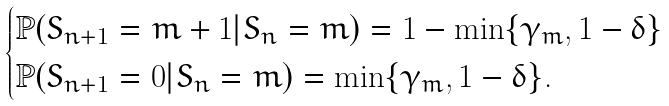Convert formula to latex. <formula><loc_0><loc_0><loc_500><loc_500>\begin{cases} \mathbb { P } ( S _ { n + 1 } = m + 1 | S _ { n } = m ) = 1 - \min \{ \gamma _ { m } , 1 - \delta \} \\ \mathbb { P } ( S _ { n + 1 } = 0 | S _ { n } = m ) = \min \{ \gamma _ { m } , 1 - \delta \} . \end{cases}</formula> 